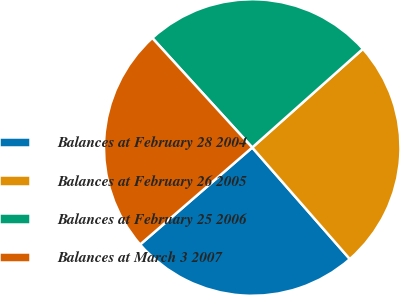Convert chart to OTSL. <chart><loc_0><loc_0><loc_500><loc_500><pie_chart><fcel>Balances at February 28 2004<fcel>Balances at February 26 2005<fcel>Balances at February 25 2006<fcel>Balances at March 3 2007<nl><fcel>25.09%<fcel>25.14%<fcel>25.19%<fcel>24.58%<nl></chart> 